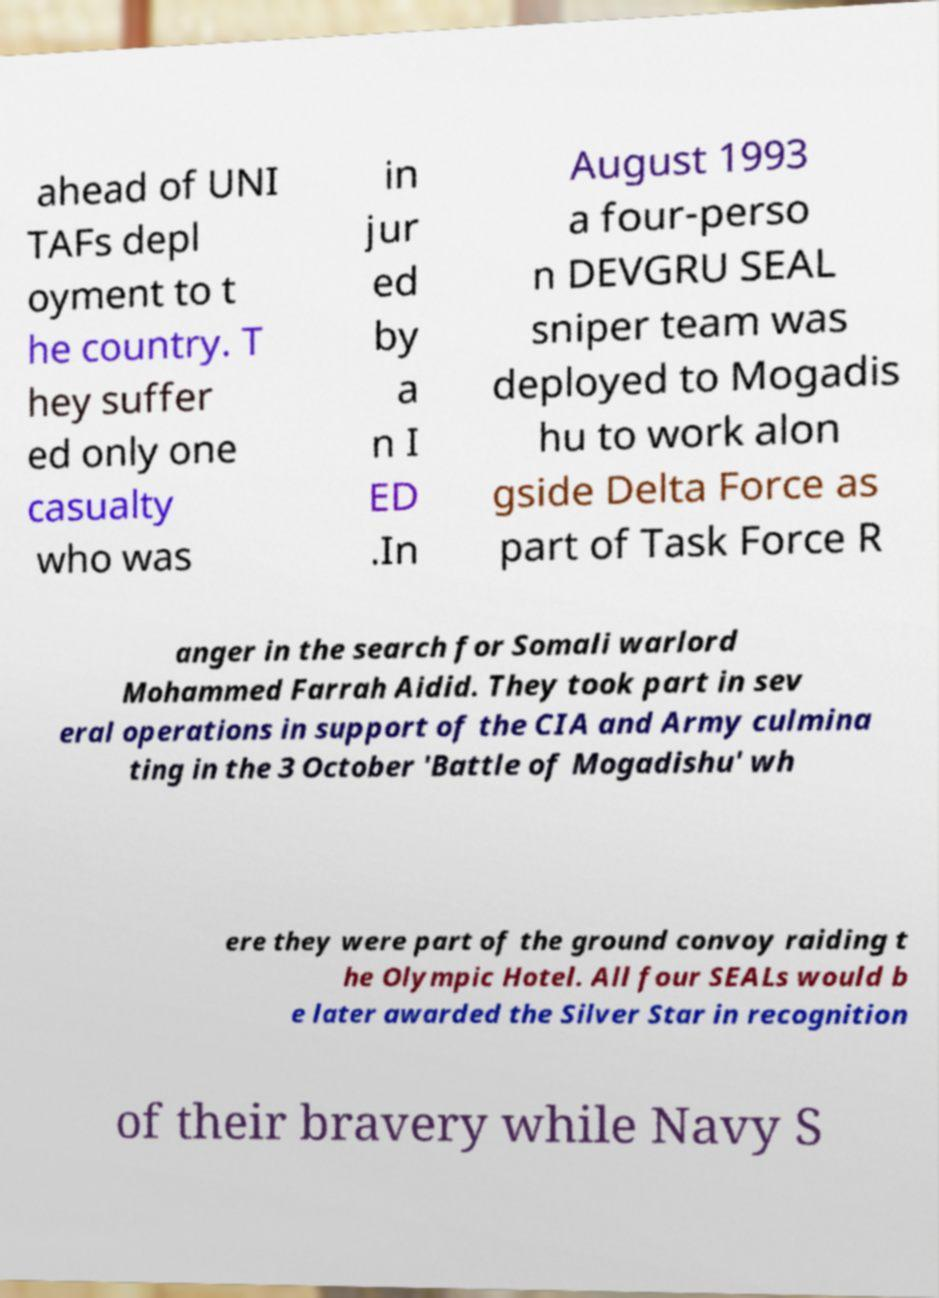Please identify and transcribe the text found in this image. ahead of UNI TAFs depl oyment to t he country. T hey suffer ed only one casualty who was in jur ed by a n I ED .In August 1993 a four-perso n DEVGRU SEAL sniper team was deployed to Mogadis hu to work alon gside Delta Force as part of Task Force R anger in the search for Somali warlord Mohammed Farrah Aidid. They took part in sev eral operations in support of the CIA and Army culmina ting in the 3 October 'Battle of Mogadishu' wh ere they were part of the ground convoy raiding t he Olympic Hotel. All four SEALs would b e later awarded the Silver Star in recognition of their bravery while Navy S 